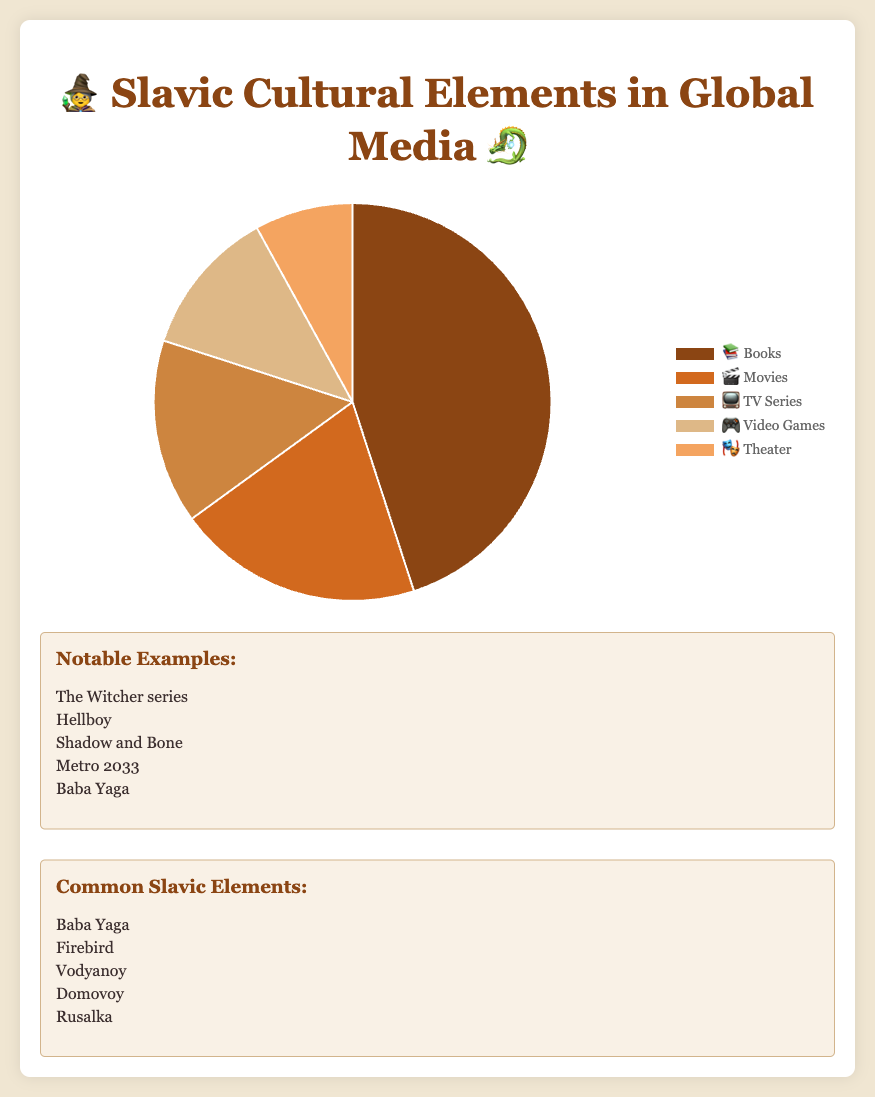What medium has the largest representation of Slavic cultural elements? According to the pie chart, books (📚) have the largest representation, accounting for 45% of Slavic cultural elements in global media.
Answer: Books Which medium has the smallest representation of Slavic cultural elements? The "Theater" (🎭) segment on the pie chart is the smallest, representing only 8% of Slavic cultural elements in global media.
Answer: Theater What is the combined representation percentage of Slavic elements in video games and TV series? The pie chart shows 12% for video games (🎮) and 15% for TV series (📺). Adding these together gives 12 + 15 = 27%.
Answer: 27% Which medium has a higher representation percentage, movies or TV series? Movies (🎬) have a 20% representation, while TV series (📺) have a 15% representation, as shown on the pie chart. Thus, movies have a higher representation.
Answer: Movies What is the difference in representation percentage between books and theater? Books (📚) have a 45% representation and theater (🎭) has 8%. Subtracting these gives 45 - 8 = 37%.
Answer: 37% What notable example corresponds to the representation of video games? Below the pie chart, the notable example associated with video games (🎮) is "Metro 2033".
Answer: Metro 2033 How many notable examples are provided for Slavic cultural elements? The information box lists 5 notable examples below the pie chart.
Answer: 5 In the pie chart, which common Slavic element appears in the highest percentage medium, and what is the medium? The highest percentage medium is books (📚) with 45% representation, and one common element displayed for books is "Baba Yaga".
Answer: Baba Yaga, Books What is the color associated with movies in the pie chart? The segment for movies (🎬) in the pie chart has a distinctive shade of orange.
Answer: Orange Which medium, according to the pie chart, has less than 20% but more than 10% representation of Slavic cultural elements? Both TV series (📺) with 15% and video games (🎮) with 12% fit this description.
Answer: TV Series, Video Games 